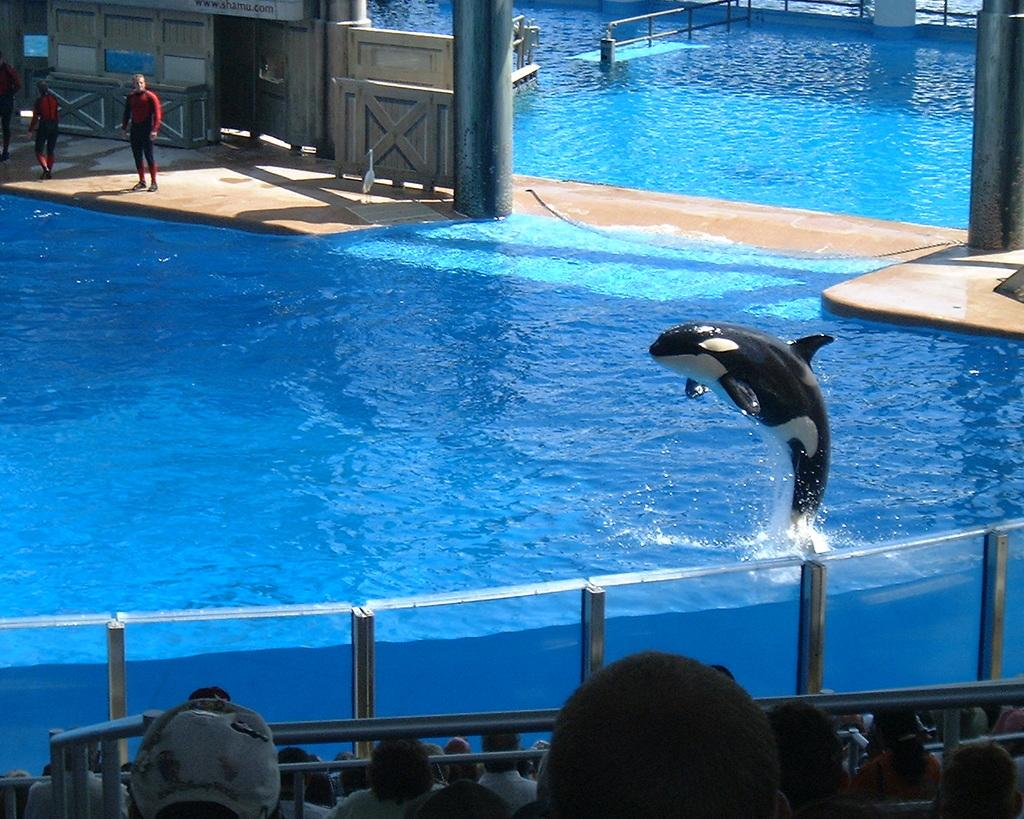What animal is featured in the image? There is a dolphin in the image. What is the dolphin doing in the image? The dolphin is jumping out of the water. Are there any people visible in the image? Yes, there are people standing on the left side of the image. What type of advertisement can be seen on the dolphin's back in the image? There is no advertisement present on the dolphin's back in the image. What kitchen utensil is being used to prepare celery in the image? There is no celery or kitchen utensil present in the image. 